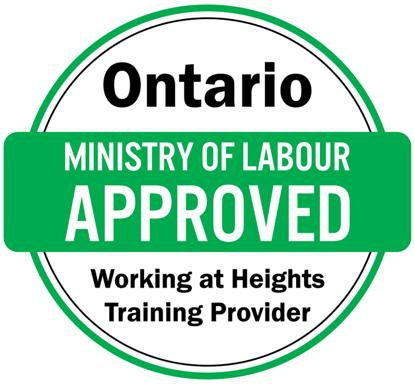What is the significance of the training being approved by the Ontario Ministry of Labour? The training's approval by the Ontario Ministry of Labour is significant because it assures that the program meets rigorous safety and educational standards set by the province. This not only boosts the credibility of the training provider but also guarantees that workers are equipped with essential skills to handle height-related occupational hazards, thus fostering a safer work environment. 